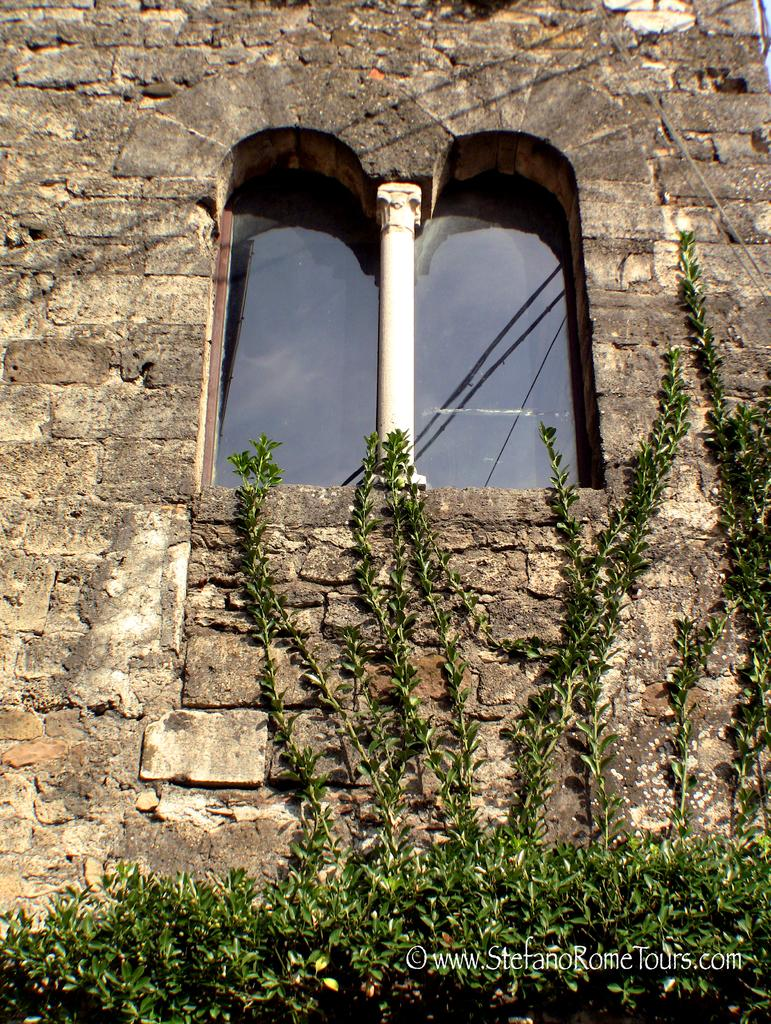What type of living organisms can be seen in the image? Plants can be seen in the image. What material is the wall in the image made of? The wall in the image is built with cobblestones. What architectural features can be observed in the image? There are windows in the image. What type of government is depicted in the image? There is no government depicted in the image; it features plants, a cobblestone wall, and windows. What organization is responsible for maintaining the plants in the image? There is no organization mentioned or depicted in the image; it only shows plants, a cobblestone wall, and windows. 